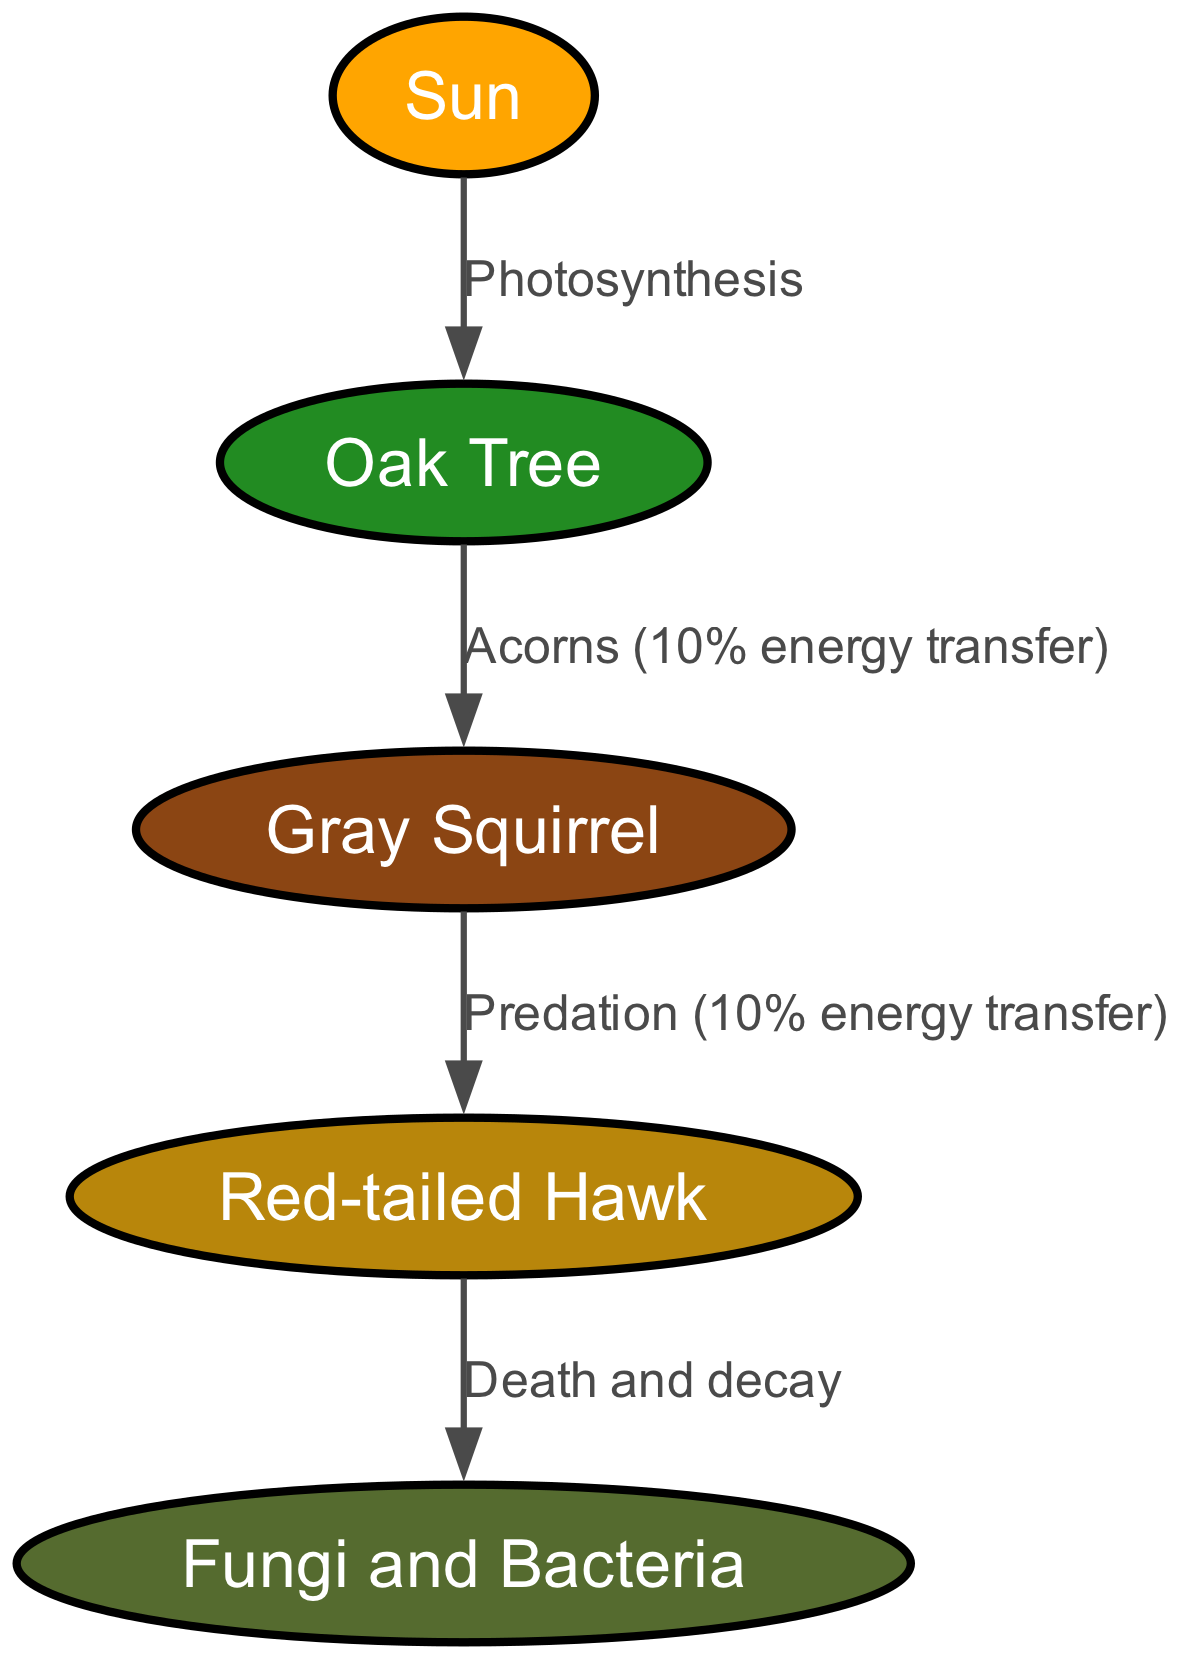What is the primary energy source for the ecosystem? The diagram indicates that the Sun is the primary energy source, as it is the first node in the food chain and represents the starting point for energy flow through photosynthesis.
Answer: Sun How many trophic levels are represented in the diagram? The diagram includes five nodes, indicating four trophic levels: producer, primary consumer, secondary consumer, and tertiary consumer. The fifth represents decomposers.
Answer: Four What energy transfer percentage occurs between the oak tree and the gray squirrel? The diagram explicitly states that the energy transfer between the oak tree and the gray squirrel is 10%, as labeled on the edge connecting these two nodes.
Answer: 10% Which organism is a secondary consumer in this food chain? By examining the nodes, the gray squirrel is identified as the secondary consumer, as it directly consumes the acorns from the oak tree, which is the primary producer.
Answer: Gray Squirrel What process connects the hawk to the decomposers in the ecosystem? The diagram shows that the hawk's connection to the decomposers is through the process labeled "Death and decay," indicating how energy flows into and nutrients are cycled back into the ecosystem after the organisms die.
Answer: Death and decay What trophic level does the red-tailed hawk occupy? The red-tailed hawk is at level 3 of the food chain, indicating it is the tertiary consumer in this ecosystem, as it directly feeds on the gray squirrel, which is a secondary consumer.
Answer: Level 3 What role do fungi and bacteria play in the ecosystem? The diagram depicts fungi and bacteria as decomposers, which are essential for breaking down dead organic matter and recycling nutrients back into the soil, supporting new plant growth and maintaining ecosystem health.
Answer: Decomposers What type of relationship is shown between the oak tree and the sun? The diagram labels the relationship between the oak tree and the sun as "Photosynthesis," indicating that the oak tree utilizes solar energy to produce food and grow, which serves as the starting point for the food chain.
Answer: Photosynthesis 